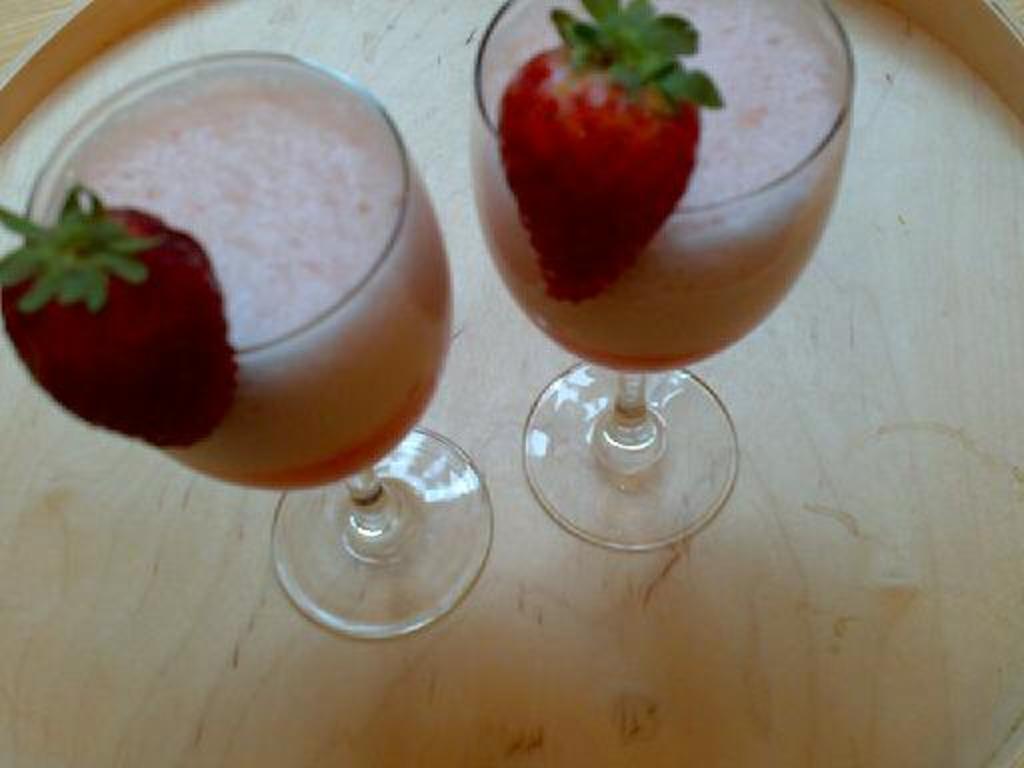Could you give a brief overview of what you see in this image? In this image we can see two glasses of juice with strawberries placed on the table. 